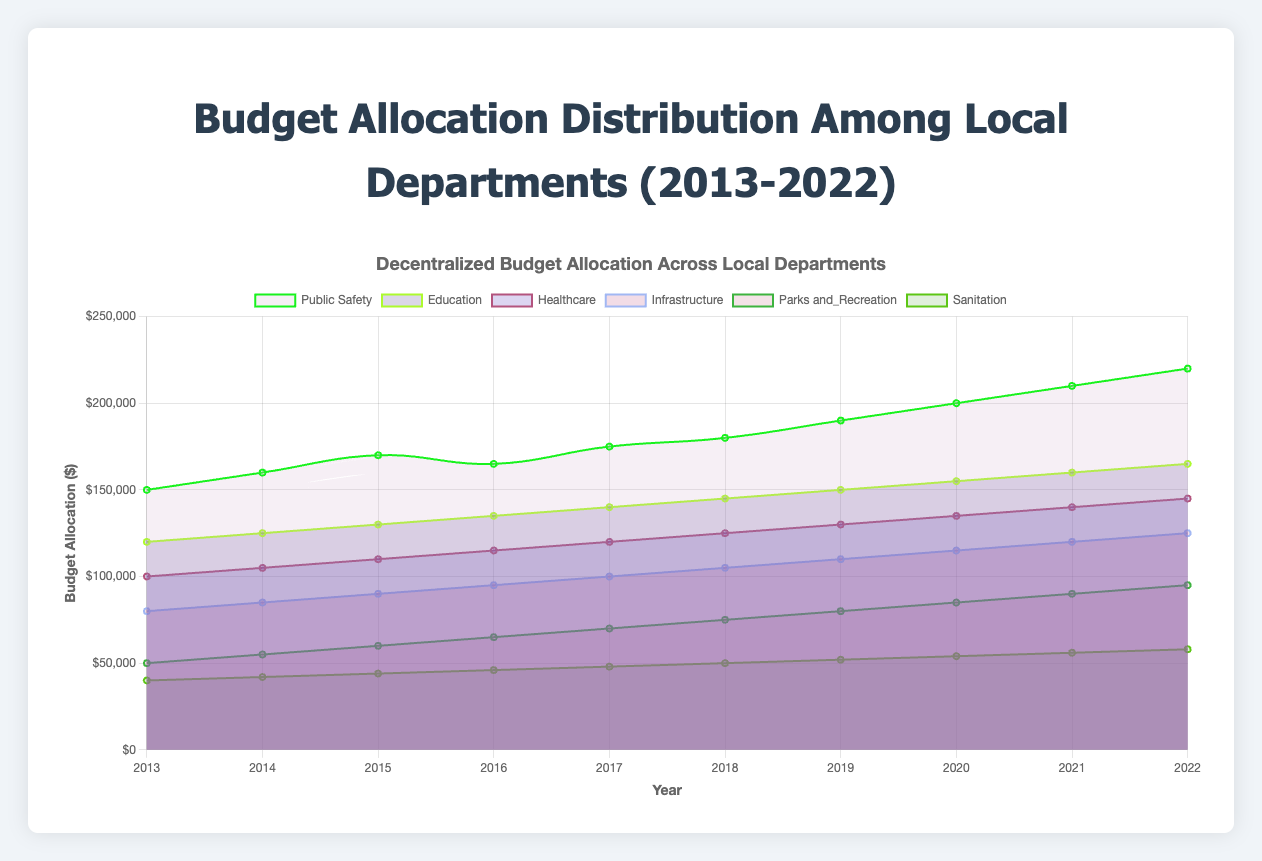Which year had the highest budget allocation for Public Safety? The year with the highest budget allocation for Public Safety is the one with the tallest area corresponding to Public Safety's data series in the plot. According to the data, it is 2022.
Answer: 2022 How does the budget allocation for Education in 2022 compare to 2013? Look at the budget allocation for Education in both 2022 and 2013. The 2022 budget is 165,000, while the 2013 budget is 120,000. Calculate the difference: 165,000 - 120,000 = 45,000.
Answer: 45,000 more in 2022 than in 2013 What is the trend of the budget allocation for Healthcare over the past decade? Observe the plotted line for Healthcare. Note the general direction of the trend from 2013 to 2022, which indicates a consistent increase from 100,000 to 145,000.
Answer: Increasing trend How did the allocation for Infrastructure change from 2018 to 2020? Check the values for Infrastructure in 2018 (105,000), 2019 (110,000), and 2020 (115,000). Calculate the year-to-year differences: 110,000 - 105,000 = 5,000 for 2019, and 115,000 - 110,000 = 5,000 for 2020, showing an increase each year.
Answer: Increased by 10,000 altogether Which department received least budget in 2015 and how much? Find the lowest value on the plot for each department in 2015. The Sanitation department has the lowest allocation with 44,000.
Answer: Sanitation, 44,000 Compare the budget for Parks and Recreation and Education in 2017. Check the values for both departments in 2017. Parks and Recreation is at 70,000, and Education is at 140,000. Education has double the budget of Parks and Recreation.
Answer: Education has double the budget of Parks and Recreation What overall trend is visible in the budget allocation for all departments combined from 2013 to 2022? Sum the budget allocations across all departments for 2013 through 2022 and observe the trend. The combined budget increases from lower values in 2013 to higher values in 2022.
Answer: Increasing trend Which department had the smallest increase in budget allocation from 2013 to 2022? Calculate the difference in budget allocation from 2013 to 2022 for each department: Public Safety (70,000), Education (45,000), Healthcare (45,000), Infrastructure (45,000), Parks and Recreation (45,000), Sanitation (18,000). Sanitation has the smallest increase.
Answer: Sanitation How did the total budget allocation of all departments change from 2013 to 2022? Sum the total allocated budget for each year from 2013 to 2022. For instance, total in 2013: 150,000 + 120,000 + 100,000 + 80,000 + 50,000 + 40,000 = 540,000. Repeat for 2022 and calculate the difference. Total in 2022: 220,000 + 165,000 + 145,000 + 125,000 + 95,000 + 58,000 = 808,000. Difference is 808,000 - 540,000 = 268,000.
Answer: Increased by 268,000 